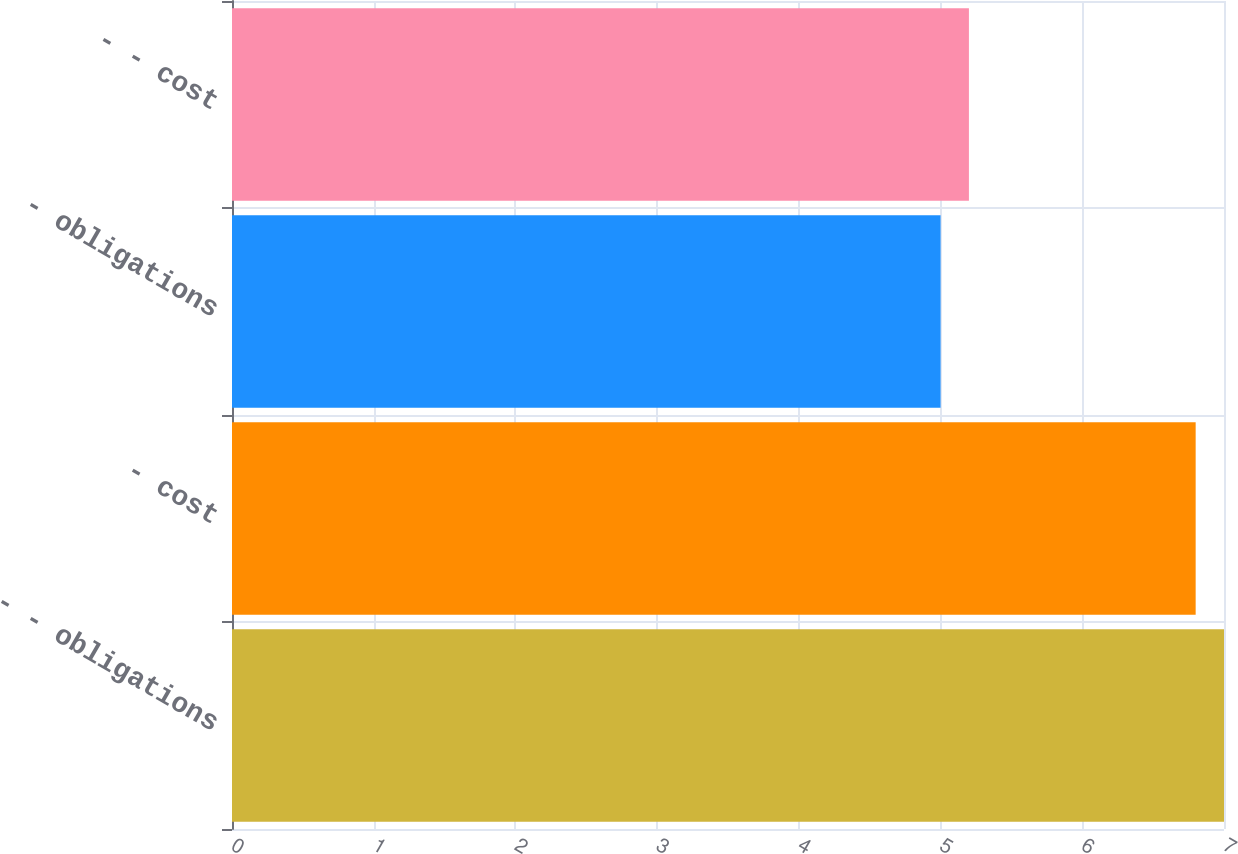Convert chart to OTSL. <chart><loc_0><loc_0><loc_500><loc_500><bar_chart><fcel>- - obligations<fcel>- cost<fcel>- obligations<fcel>- - cost<nl><fcel>7<fcel>6.8<fcel>5<fcel>5.2<nl></chart> 